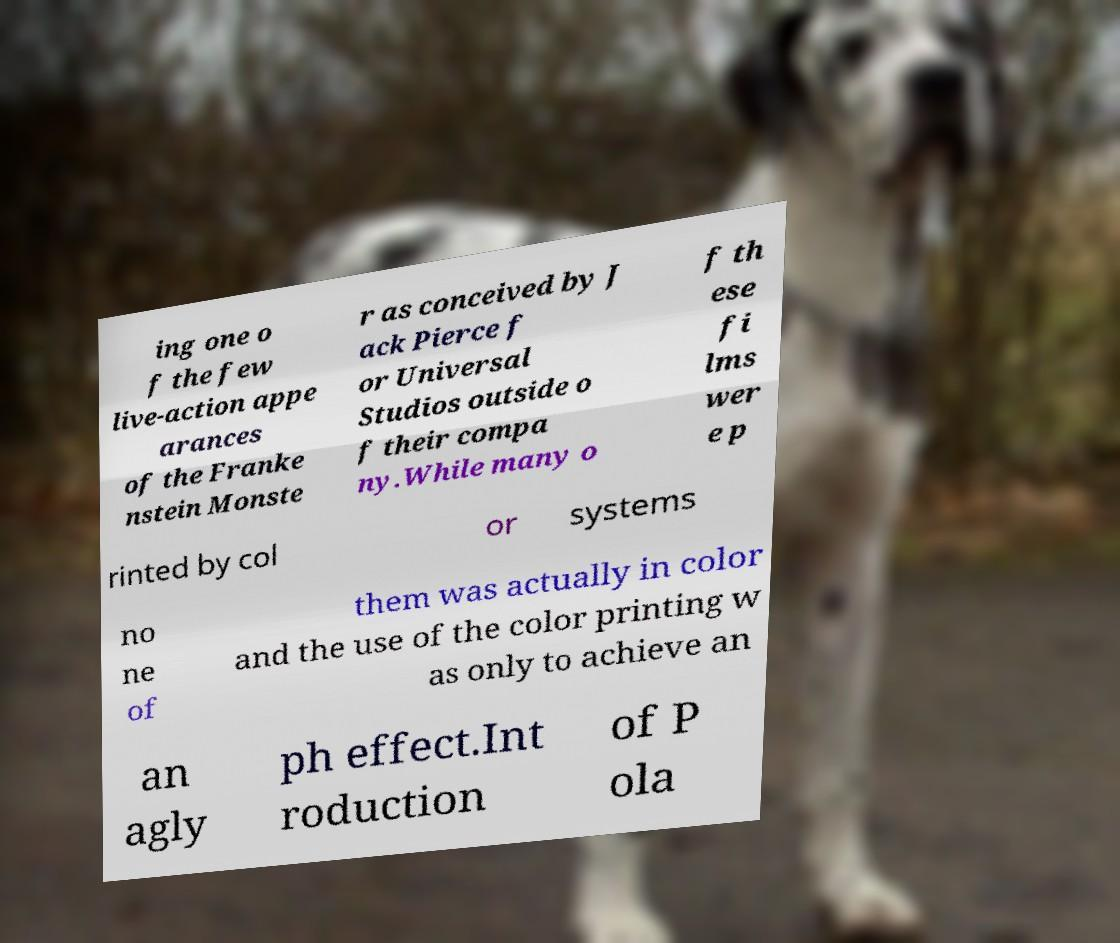Could you extract and type out the text from this image? ing one o f the few live-action appe arances of the Franke nstein Monste r as conceived by J ack Pierce f or Universal Studios outside o f their compa ny.While many o f th ese fi lms wer e p rinted by col or systems no ne of them was actually in color and the use of the color printing w as only to achieve an an agly ph effect.Int roduction of P ola 